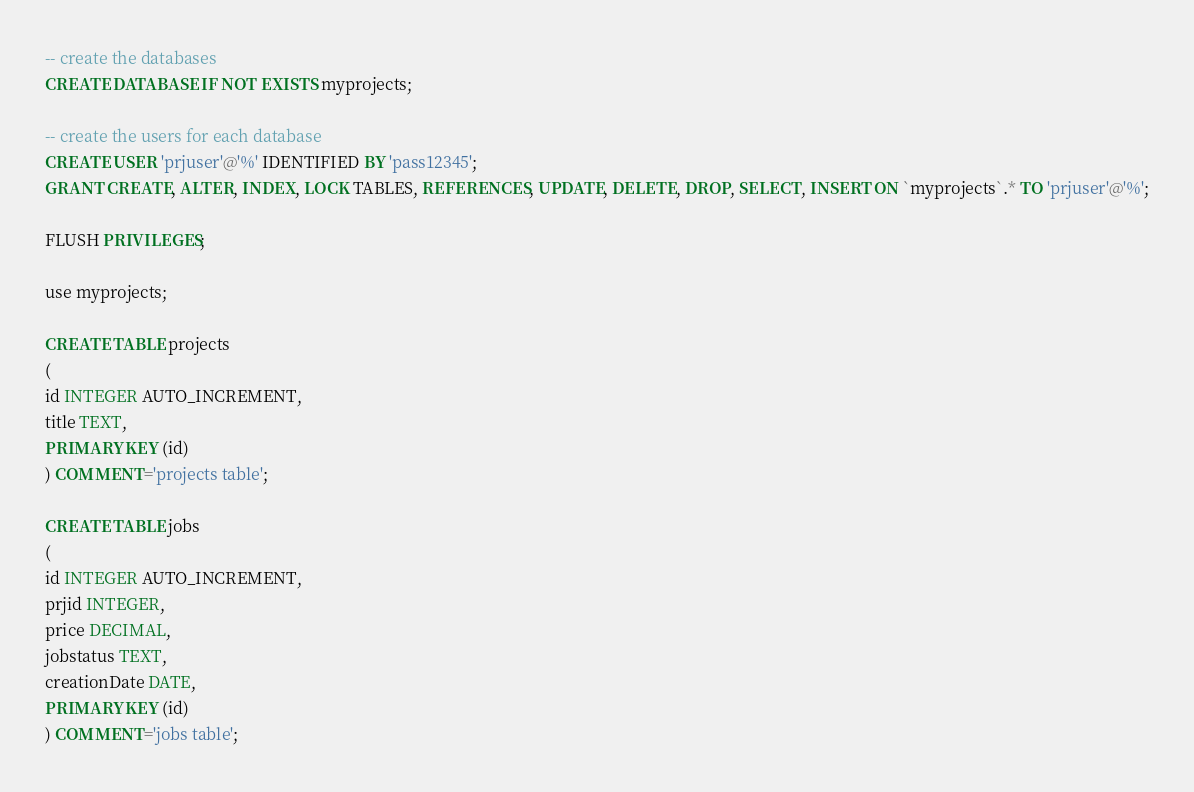<code> <loc_0><loc_0><loc_500><loc_500><_SQL_>-- create the databases
CREATE DATABASE IF NOT EXISTS myprojects;

-- create the users for each database
CREATE USER 'prjuser'@'%' IDENTIFIED BY 'pass12345';
GRANT CREATE, ALTER, INDEX, LOCK TABLES, REFERENCES, UPDATE, DELETE, DROP, SELECT, INSERT ON `myprojects`.* TO 'prjuser'@'%';

FLUSH PRIVILEGES;

use myprojects;

CREATE TABLE projects
(
id INTEGER AUTO_INCREMENT,
title TEXT,
PRIMARY KEY (id)
) COMMENT='projects table';

CREATE TABLE jobs
(
id INTEGER AUTO_INCREMENT,
prjid INTEGER,
price DECIMAL,
jobstatus TEXT,
creationDate DATE,
PRIMARY KEY (id)
) COMMENT='jobs table';</code> 